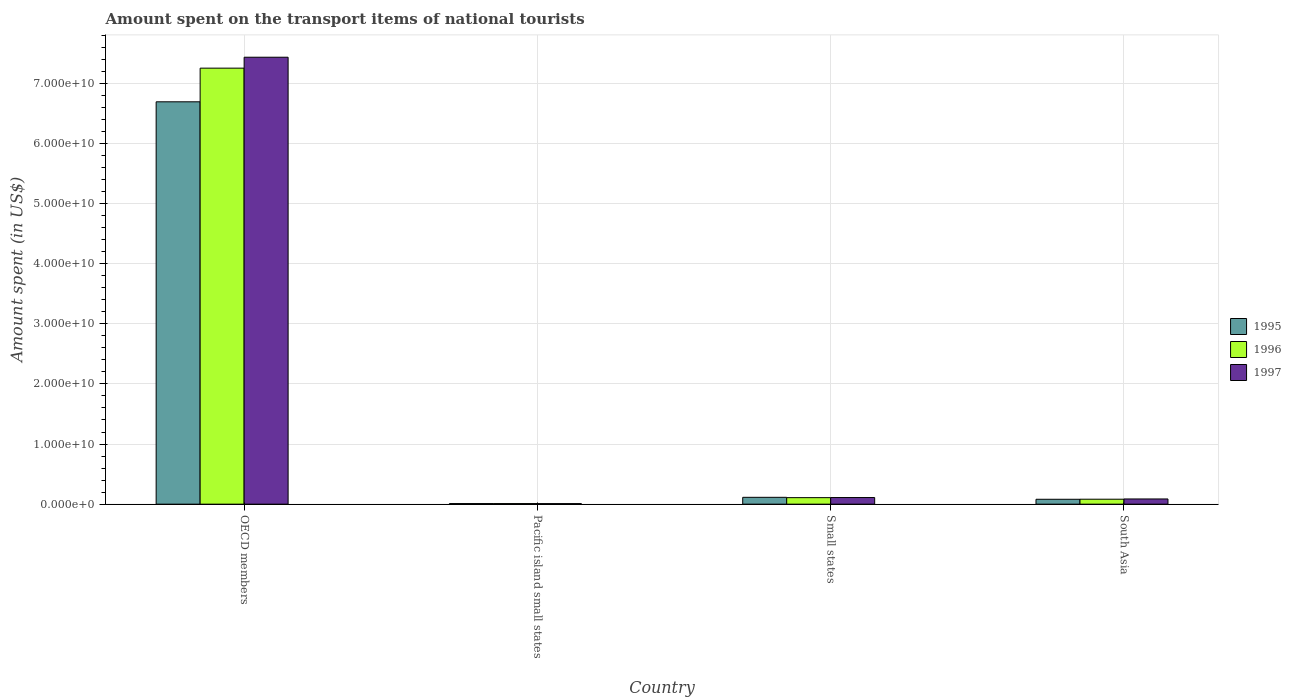How many bars are there on the 4th tick from the left?
Give a very brief answer. 3. What is the label of the 4th group of bars from the left?
Offer a very short reply. South Asia. What is the amount spent on the transport items of national tourists in 1997 in OECD members?
Provide a succinct answer. 7.43e+1. Across all countries, what is the maximum amount spent on the transport items of national tourists in 1995?
Your answer should be compact. 6.69e+1. Across all countries, what is the minimum amount spent on the transport items of national tourists in 1997?
Ensure brevity in your answer.  8.96e+07. In which country was the amount spent on the transport items of national tourists in 1997 minimum?
Your answer should be very brief. Pacific island small states. What is the total amount spent on the transport items of national tourists in 1995 in the graph?
Give a very brief answer. 6.90e+1. What is the difference between the amount spent on the transport items of national tourists in 1996 in OECD members and that in Pacific island small states?
Your answer should be compact. 7.24e+1. What is the difference between the amount spent on the transport items of national tourists in 1996 in Small states and the amount spent on the transport items of national tourists in 1997 in OECD members?
Offer a terse response. -7.32e+1. What is the average amount spent on the transport items of national tourists in 1997 per country?
Offer a terse response. 1.91e+1. What is the difference between the amount spent on the transport items of national tourists of/in 1996 and amount spent on the transport items of national tourists of/in 1997 in OECD members?
Provide a succinct answer. -1.82e+09. What is the ratio of the amount spent on the transport items of national tourists in 1997 in Pacific island small states to that in South Asia?
Provide a short and direct response. 0.1. Is the amount spent on the transport items of national tourists in 1995 in Small states less than that in South Asia?
Provide a short and direct response. No. What is the difference between the highest and the second highest amount spent on the transport items of national tourists in 1997?
Give a very brief answer. 7.32e+1. What is the difference between the highest and the lowest amount spent on the transport items of national tourists in 1997?
Offer a very short reply. 7.42e+1. Is the sum of the amount spent on the transport items of national tourists in 1996 in Pacific island small states and Small states greater than the maximum amount spent on the transport items of national tourists in 1997 across all countries?
Your answer should be compact. No. Is it the case that in every country, the sum of the amount spent on the transport items of national tourists in 1997 and amount spent on the transport items of national tourists in 1996 is greater than the amount spent on the transport items of national tourists in 1995?
Provide a short and direct response. Yes. How many bars are there?
Provide a succinct answer. 12. Are all the bars in the graph horizontal?
Your answer should be compact. No. What is the difference between two consecutive major ticks on the Y-axis?
Your answer should be compact. 1.00e+1. Are the values on the major ticks of Y-axis written in scientific E-notation?
Provide a short and direct response. Yes. What is the title of the graph?
Provide a short and direct response. Amount spent on the transport items of national tourists. Does "1976" appear as one of the legend labels in the graph?
Ensure brevity in your answer.  No. What is the label or title of the Y-axis?
Your answer should be very brief. Amount spent (in US$). What is the Amount spent (in US$) in 1995 in OECD members?
Offer a terse response. 6.69e+1. What is the Amount spent (in US$) of 1996 in OECD members?
Ensure brevity in your answer.  7.25e+1. What is the Amount spent (in US$) in 1997 in OECD members?
Keep it short and to the point. 7.43e+1. What is the Amount spent (in US$) in 1995 in Pacific island small states?
Provide a succinct answer. 9.96e+07. What is the Amount spent (in US$) of 1996 in Pacific island small states?
Give a very brief answer. 9.76e+07. What is the Amount spent (in US$) of 1997 in Pacific island small states?
Ensure brevity in your answer.  8.96e+07. What is the Amount spent (in US$) in 1995 in Small states?
Your answer should be compact. 1.14e+09. What is the Amount spent (in US$) in 1996 in Small states?
Your answer should be compact. 1.08e+09. What is the Amount spent (in US$) of 1997 in Small states?
Offer a very short reply. 1.10e+09. What is the Amount spent (in US$) of 1995 in South Asia?
Give a very brief answer. 8.12e+08. What is the Amount spent (in US$) in 1996 in South Asia?
Your answer should be very brief. 8.23e+08. What is the Amount spent (in US$) of 1997 in South Asia?
Keep it short and to the point. 8.66e+08. Across all countries, what is the maximum Amount spent (in US$) of 1995?
Your response must be concise. 6.69e+1. Across all countries, what is the maximum Amount spent (in US$) in 1996?
Make the answer very short. 7.25e+1. Across all countries, what is the maximum Amount spent (in US$) of 1997?
Offer a terse response. 7.43e+1. Across all countries, what is the minimum Amount spent (in US$) of 1995?
Your response must be concise. 9.96e+07. Across all countries, what is the minimum Amount spent (in US$) in 1996?
Provide a short and direct response. 9.76e+07. Across all countries, what is the minimum Amount spent (in US$) of 1997?
Offer a terse response. 8.96e+07. What is the total Amount spent (in US$) of 1995 in the graph?
Your response must be concise. 6.90e+1. What is the total Amount spent (in US$) of 1996 in the graph?
Offer a very short reply. 7.45e+1. What is the total Amount spent (in US$) in 1997 in the graph?
Give a very brief answer. 7.64e+1. What is the difference between the Amount spent (in US$) in 1995 in OECD members and that in Pacific island small states?
Provide a succinct answer. 6.68e+1. What is the difference between the Amount spent (in US$) of 1996 in OECD members and that in Pacific island small states?
Keep it short and to the point. 7.24e+1. What is the difference between the Amount spent (in US$) in 1997 in OECD members and that in Pacific island small states?
Your response must be concise. 7.42e+1. What is the difference between the Amount spent (in US$) of 1995 in OECD members and that in Small states?
Provide a short and direct response. 6.58e+1. What is the difference between the Amount spent (in US$) of 1996 in OECD members and that in Small states?
Provide a succinct answer. 7.14e+1. What is the difference between the Amount spent (in US$) in 1997 in OECD members and that in Small states?
Offer a terse response. 7.32e+1. What is the difference between the Amount spent (in US$) of 1995 in OECD members and that in South Asia?
Give a very brief answer. 6.61e+1. What is the difference between the Amount spent (in US$) in 1996 in OECD members and that in South Asia?
Provide a short and direct response. 7.17e+1. What is the difference between the Amount spent (in US$) of 1997 in OECD members and that in South Asia?
Your answer should be compact. 7.35e+1. What is the difference between the Amount spent (in US$) in 1995 in Pacific island small states and that in Small states?
Provide a short and direct response. -1.04e+09. What is the difference between the Amount spent (in US$) of 1996 in Pacific island small states and that in Small states?
Offer a very short reply. -9.86e+08. What is the difference between the Amount spent (in US$) in 1997 in Pacific island small states and that in Small states?
Offer a terse response. -1.01e+09. What is the difference between the Amount spent (in US$) in 1995 in Pacific island small states and that in South Asia?
Your answer should be very brief. -7.12e+08. What is the difference between the Amount spent (in US$) in 1996 in Pacific island small states and that in South Asia?
Your answer should be very brief. -7.25e+08. What is the difference between the Amount spent (in US$) in 1997 in Pacific island small states and that in South Asia?
Offer a very short reply. -7.76e+08. What is the difference between the Amount spent (in US$) in 1995 in Small states and that in South Asia?
Your answer should be compact. 3.25e+08. What is the difference between the Amount spent (in US$) in 1996 in Small states and that in South Asia?
Your response must be concise. 2.60e+08. What is the difference between the Amount spent (in US$) in 1997 in Small states and that in South Asia?
Offer a very short reply. 2.35e+08. What is the difference between the Amount spent (in US$) in 1995 in OECD members and the Amount spent (in US$) in 1996 in Pacific island small states?
Give a very brief answer. 6.68e+1. What is the difference between the Amount spent (in US$) in 1995 in OECD members and the Amount spent (in US$) in 1997 in Pacific island small states?
Provide a succinct answer. 6.68e+1. What is the difference between the Amount spent (in US$) of 1996 in OECD members and the Amount spent (in US$) of 1997 in Pacific island small states?
Keep it short and to the point. 7.24e+1. What is the difference between the Amount spent (in US$) in 1995 in OECD members and the Amount spent (in US$) in 1996 in Small states?
Give a very brief answer. 6.58e+1. What is the difference between the Amount spent (in US$) of 1995 in OECD members and the Amount spent (in US$) of 1997 in Small states?
Provide a succinct answer. 6.58e+1. What is the difference between the Amount spent (in US$) of 1996 in OECD members and the Amount spent (in US$) of 1997 in Small states?
Offer a terse response. 7.14e+1. What is the difference between the Amount spent (in US$) of 1995 in OECD members and the Amount spent (in US$) of 1996 in South Asia?
Provide a succinct answer. 6.61e+1. What is the difference between the Amount spent (in US$) in 1995 in OECD members and the Amount spent (in US$) in 1997 in South Asia?
Your response must be concise. 6.60e+1. What is the difference between the Amount spent (in US$) of 1996 in OECD members and the Amount spent (in US$) of 1997 in South Asia?
Your answer should be compact. 7.16e+1. What is the difference between the Amount spent (in US$) of 1995 in Pacific island small states and the Amount spent (in US$) of 1996 in Small states?
Your answer should be compact. -9.84e+08. What is the difference between the Amount spent (in US$) of 1995 in Pacific island small states and the Amount spent (in US$) of 1997 in Small states?
Make the answer very short. -1.00e+09. What is the difference between the Amount spent (in US$) of 1996 in Pacific island small states and the Amount spent (in US$) of 1997 in Small states?
Ensure brevity in your answer.  -1.00e+09. What is the difference between the Amount spent (in US$) of 1995 in Pacific island small states and the Amount spent (in US$) of 1996 in South Asia?
Offer a very short reply. -7.23e+08. What is the difference between the Amount spent (in US$) of 1995 in Pacific island small states and the Amount spent (in US$) of 1997 in South Asia?
Your answer should be compact. -7.66e+08. What is the difference between the Amount spent (in US$) of 1996 in Pacific island small states and the Amount spent (in US$) of 1997 in South Asia?
Provide a short and direct response. -7.68e+08. What is the difference between the Amount spent (in US$) of 1995 in Small states and the Amount spent (in US$) of 1996 in South Asia?
Offer a very short reply. 3.15e+08. What is the difference between the Amount spent (in US$) in 1995 in Small states and the Amount spent (in US$) in 1997 in South Asia?
Give a very brief answer. 2.72e+08. What is the difference between the Amount spent (in US$) of 1996 in Small states and the Amount spent (in US$) of 1997 in South Asia?
Your answer should be compact. 2.18e+08. What is the average Amount spent (in US$) in 1995 per country?
Your answer should be compact. 1.72e+1. What is the average Amount spent (in US$) of 1996 per country?
Your answer should be compact. 1.86e+1. What is the average Amount spent (in US$) of 1997 per country?
Give a very brief answer. 1.91e+1. What is the difference between the Amount spent (in US$) of 1995 and Amount spent (in US$) of 1996 in OECD members?
Ensure brevity in your answer.  -5.60e+09. What is the difference between the Amount spent (in US$) of 1995 and Amount spent (in US$) of 1997 in OECD members?
Your answer should be compact. -7.41e+09. What is the difference between the Amount spent (in US$) in 1996 and Amount spent (in US$) in 1997 in OECD members?
Make the answer very short. -1.82e+09. What is the difference between the Amount spent (in US$) in 1995 and Amount spent (in US$) in 1996 in Pacific island small states?
Provide a succinct answer. 1.99e+06. What is the difference between the Amount spent (in US$) of 1995 and Amount spent (in US$) of 1997 in Pacific island small states?
Offer a terse response. 9.93e+06. What is the difference between the Amount spent (in US$) in 1996 and Amount spent (in US$) in 1997 in Pacific island small states?
Keep it short and to the point. 7.94e+06. What is the difference between the Amount spent (in US$) of 1995 and Amount spent (in US$) of 1996 in Small states?
Provide a short and direct response. 5.44e+07. What is the difference between the Amount spent (in US$) in 1995 and Amount spent (in US$) in 1997 in Small states?
Offer a very short reply. 3.69e+07. What is the difference between the Amount spent (in US$) in 1996 and Amount spent (in US$) in 1997 in Small states?
Ensure brevity in your answer.  -1.75e+07. What is the difference between the Amount spent (in US$) in 1995 and Amount spent (in US$) in 1996 in South Asia?
Offer a terse response. -1.09e+07. What is the difference between the Amount spent (in US$) in 1995 and Amount spent (in US$) in 1997 in South Asia?
Provide a succinct answer. -5.35e+07. What is the difference between the Amount spent (in US$) in 1996 and Amount spent (in US$) in 1997 in South Asia?
Your response must be concise. -4.25e+07. What is the ratio of the Amount spent (in US$) in 1995 in OECD members to that in Pacific island small states?
Ensure brevity in your answer.  672.09. What is the ratio of the Amount spent (in US$) of 1996 in OECD members to that in Pacific island small states?
Offer a very short reply. 743.18. What is the ratio of the Amount spent (in US$) of 1997 in OECD members to that in Pacific island small states?
Your answer should be compact. 829.26. What is the ratio of the Amount spent (in US$) in 1995 in OECD members to that in Small states?
Offer a terse response. 58.82. What is the ratio of the Amount spent (in US$) in 1996 in OECD members to that in Small states?
Give a very brief answer. 66.95. What is the ratio of the Amount spent (in US$) in 1997 in OECD members to that in Small states?
Keep it short and to the point. 67.53. What is the ratio of the Amount spent (in US$) in 1995 in OECD members to that in South Asia?
Your response must be concise. 82.4. What is the ratio of the Amount spent (in US$) in 1996 in OECD members to that in South Asia?
Keep it short and to the point. 88.11. What is the ratio of the Amount spent (in US$) of 1997 in OECD members to that in South Asia?
Keep it short and to the point. 85.87. What is the ratio of the Amount spent (in US$) in 1995 in Pacific island small states to that in Small states?
Offer a terse response. 0.09. What is the ratio of the Amount spent (in US$) of 1996 in Pacific island small states to that in Small states?
Provide a short and direct response. 0.09. What is the ratio of the Amount spent (in US$) in 1997 in Pacific island small states to that in Small states?
Give a very brief answer. 0.08. What is the ratio of the Amount spent (in US$) of 1995 in Pacific island small states to that in South Asia?
Provide a succinct answer. 0.12. What is the ratio of the Amount spent (in US$) in 1996 in Pacific island small states to that in South Asia?
Make the answer very short. 0.12. What is the ratio of the Amount spent (in US$) in 1997 in Pacific island small states to that in South Asia?
Make the answer very short. 0.1. What is the ratio of the Amount spent (in US$) in 1995 in Small states to that in South Asia?
Provide a short and direct response. 1.4. What is the ratio of the Amount spent (in US$) of 1996 in Small states to that in South Asia?
Offer a terse response. 1.32. What is the ratio of the Amount spent (in US$) of 1997 in Small states to that in South Asia?
Make the answer very short. 1.27. What is the difference between the highest and the second highest Amount spent (in US$) of 1995?
Your answer should be compact. 6.58e+1. What is the difference between the highest and the second highest Amount spent (in US$) of 1996?
Make the answer very short. 7.14e+1. What is the difference between the highest and the second highest Amount spent (in US$) of 1997?
Keep it short and to the point. 7.32e+1. What is the difference between the highest and the lowest Amount spent (in US$) of 1995?
Your response must be concise. 6.68e+1. What is the difference between the highest and the lowest Amount spent (in US$) of 1996?
Make the answer very short. 7.24e+1. What is the difference between the highest and the lowest Amount spent (in US$) in 1997?
Provide a succinct answer. 7.42e+1. 